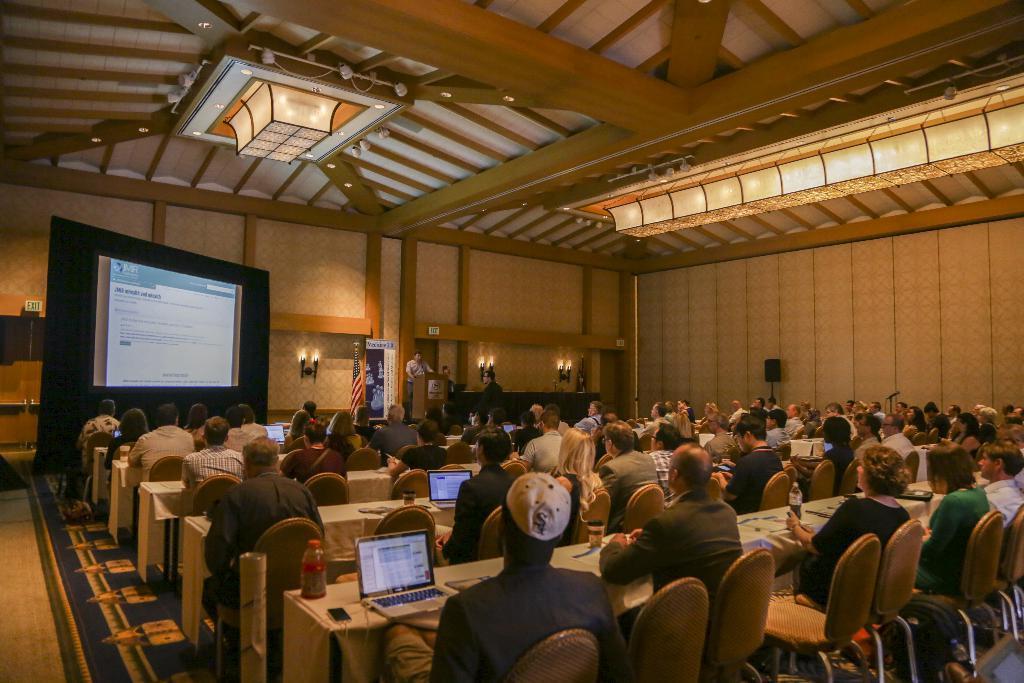Can you describe this image briefly? There are few persons sitting on the chairs at the tables and on the tables we can see bottles, laptops and other objects. In the background there is a screen, lights and objects on the wall, hoarding and a person is standing at the podium and on the right side we can see a speaker on a stand and a mic on another stand. 